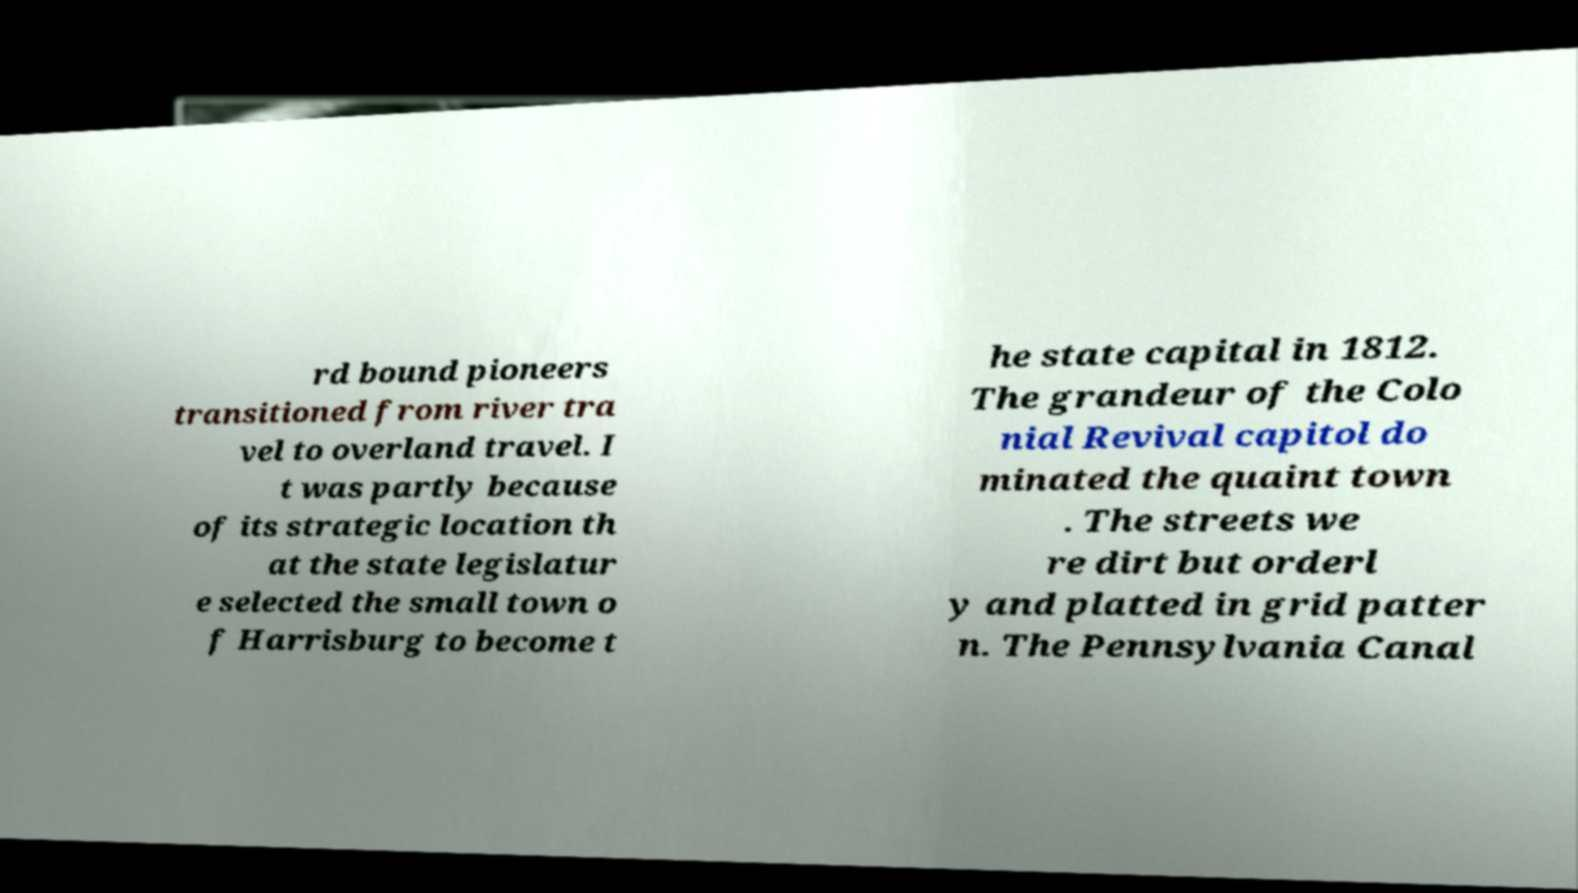Can you read and provide the text displayed in the image?This photo seems to have some interesting text. Can you extract and type it out for me? rd bound pioneers transitioned from river tra vel to overland travel. I t was partly because of its strategic location th at the state legislatur e selected the small town o f Harrisburg to become t he state capital in 1812. The grandeur of the Colo nial Revival capitol do minated the quaint town . The streets we re dirt but orderl y and platted in grid patter n. The Pennsylvania Canal 